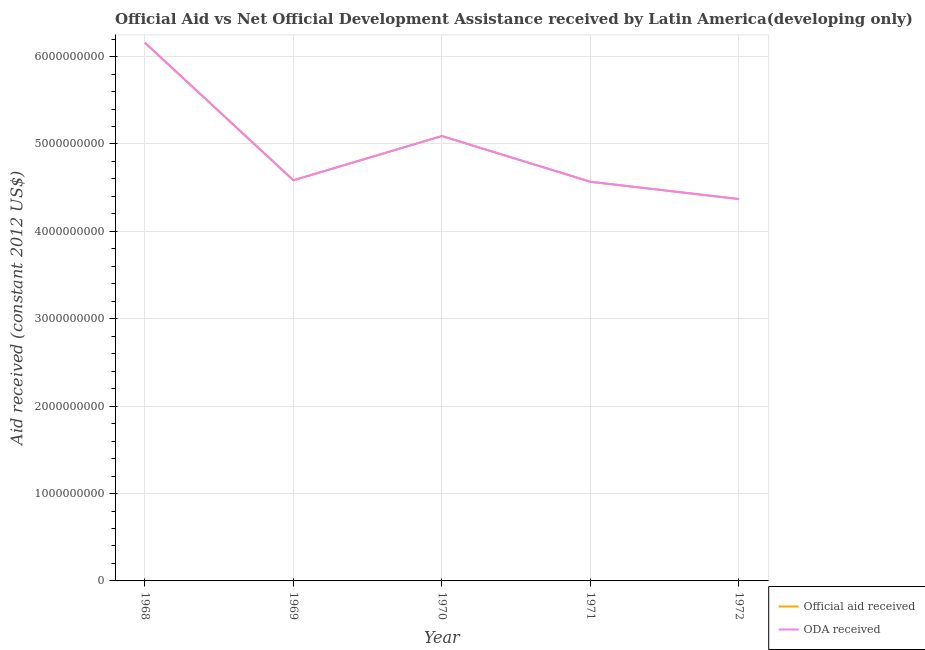How many different coloured lines are there?
Your answer should be very brief. 2. Is the number of lines equal to the number of legend labels?
Make the answer very short. Yes. What is the official aid received in 1969?
Your answer should be compact. 4.58e+09. Across all years, what is the maximum oda received?
Provide a short and direct response. 6.16e+09. Across all years, what is the minimum official aid received?
Offer a terse response. 4.37e+09. In which year was the official aid received maximum?
Give a very brief answer. 1968. What is the total official aid received in the graph?
Give a very brief answer. 2.48e+1. What is the difference between the official aid received in 1969 and that in 1971?
Make the answer very short. 1.72e+07. What is the difference between the oda received in 1971 and the official aid received in 1968?
Provide a short and direct response. -1.59e+09. What is the average official aid received per year?
Give a very brief answer. 4.95e+09. In the year 1969, what is the difference between the oda received and official aid received?
Keep it short and to the point. 0. What is the ratio of the oda received in 1968 to that in 1970?
Your response must be concise. 1.21. Is the difference between the oda received in 1971 and 1972 greater than the difference between the official aid received in 1971 and 1972?
Your response must be concise. No. What is the difference between the highest and the second highest official aid received?
Give a very brief answer. 1.07e+09. What is the difference between the highest and the lowest oda received?
Keep it short and to the point. 1.79e+09. In how many years, is the oda received greater than the average oda received taken over all years?
Your response must be concise. 2. Does the official aid received monotonically increase over the years?
Give a very brief answer. No. Is the official aid received strictly less than the oda received over the years?
Give a very brief answer. No. How many lines are there?
Keep it short and to the point. 2. What is the difference between two consecutive major ticks on the Y-axis?
Your response must be concise. 1.00e+09. What is the title of the graph?
Keep it short and to the point. Official Aid vs Net Official Development Assistance received by Latin America(developing only) . Does "Crop" appear as one of the legend labels in the graph?
Ensure brevity in your answer.  No. What is the label or title of the X-axis?
Provide a succinct answer. Year. What is the label or title of the Y-axis?
Your response must be concise. Aid received (constant 2012 US$). What is the Aid received (constant 2012 US$) in Official aid received in 1968?
Provide a short and direct response. 6.16e+09. What is the Aid received (constant 2012 US$) of ODA received in 1968?
Provide a short and direct response. 6.16e+09. What is the Aid received (constant 2012 US$) of Official aid received in 1969?
Provide a succinct answer. 4.58e+09. What is the Aid received (constant 2012 US$) in ODA received in 1969?
Provide a succinct answer. 4.58e+09. What is the Aid received (constant 2012 US$) of Official aid received in 1970?
Ensure brevity in your answer.  5.09e+09. What is the Aid received (constant 2012 US$) of ODA received in 1970?
Your answer should be compact. 5.09e+09. What is the Aid received (constant 2012 US$) of Official aid received in 1971?
Offer a very short reply. 4.57e+09. What is the Aid received (constant 2012 US$) of ODA received in 1971?
Offer a terse response. 4.57e+09. What is the Aid received (constant 2012 US$) of Official aid received in 1972?
Ensure brevity in your answer.  4.37e+09. What is the Aid received (constant 2012 US$) of ODA received in 1972?
Ensure brevity in your answer.  4.37e+09. Across all years, what is the maximum Aid received (constant 2012 US$) of Official aid received?
Provide a short and direct response. 6.16e+09. Across all years, what is the maximum Aid received (constant 2012 US$) in ODA received?
Ensure brevity in your answer.  6.16e+09. Across all years, what is the minimum Aid received (constant 2012 US$) of Official aid received?
Your answer should be compact. 4.37e+09. Across all years, what is the minimum Aid received (constant 2012 US$) of ODA received?
Offer a very short reply. 4.37e+09. What is the total Aid received (constant 2012 US$) of Official aid received in the graph?
Make the answer very short. 2.48e+1. What is the total Aid received (constant 2012 US$) of ODA received in the graph?
Your answer should be compact. 2.48e+1. What is the difference between the Aid received (constant 2012 US$) in Official aid received in 1968 and that in 1969?
Offer a very short reply. 1.57e+09. What is the difference between the Aid received (constant 2012 US$) of ODA received in 1968 and that in 1969?
Ensure brevity in your answer.  1.57e+09. What is the difference between the Aid received (constant 2012 US$) of Official aid received in 1968 and that in 1970?
Make the answer very short. 1.07e+09. What is the difference between the Aid received (constant 2012 US$) in ODA received in 1968 and that in 1970?
Keep it short and to the point. 1.07e+09. What is the difference between the Aid received (constant 2012 US$) of Official aid received in 1968 and that in 1971?
Give a very brief answer. 1.59e+09. What is the difference between the Aid received (constant 2012 US$) in ODA received in 1968 and that in 1971?
Offer a terse response. 1.59e+09. What is the difference between the Aid received (constant 2012 US$) of Official aid received in 1968 and that in 1972?
Your answer should be compact. 1.79e+09. What is the difference between the Aid received (constant 2012 US$) in ODA received in 1968 and that in 1972?
Your answer should be very brief. 1.79e+09. What is the difference between the Aid received (constant 2012 US$) in Official aid received in 1969 and that in 1970?
Offer a very short reply. -5.06e+08. What is the difference between the Aid received (constant 2012 US$) in ODA received in 1969 and that in 1970?
Your answer should be very brief. -5.06e+08. What is the difference between the Aid received (constant 2012 US$) in Official aid received in 1969 and that in 1971?
Keep it short and to the point. 1.72e+07. What is the difference between the Aid received (constant 2012 US$) of ODA received in 1969 and that in 1971?
Offer a terse response. 1.72e+07. What is the difference between the Aid received (constant 2012 US$) of Official aid received in 1969 and that in 1972?
Provide a short and direct response. 2.15e+08. What is the difference between the Aid received (constant 2012 US$) in ODA received in 1969 and that in 1972?
Your answer should be very brief. 2.15e+08. What is the difference between the Aid received (constant 2012 US$) of Official aid received in 1970 and that in 1971?
Your response must be concise. 5.23e+08. What is the difference between the Aid received (constant 2012 US$) in ODA received in 1970 and that in 1971?
Your response must be concise. 5.23e+08. What is the difference between the Aid received (constant 2012 US$) of Official aid received in 1970 and that in 1972?
Your response must be concise. 7.21e+08. What is the difference between the Aid received (constant 2012 US$) in ODA received in 1970 and that in 1972?
Your answer should be very brief. 7.21e+08. What is the difference between the Aid received (constant 2012 US$) in Official aid received in 1971 and that in 1972?
Your answer should be compact. 1.98e+08. What is the difference between the Aid received (constant 2012 US$) in ODA received in 1971 and that in 1972?
Provide a short and direct response. 1.98e+08. What is the difference between the Aid received (constant 2012 US$) in Official aid received in 1968 and the Aid received (constant 2012 US$) in ODA received in 1969?
Ensure brevity in your answer.  1.57e+09. What is the difference between the Aid received (constant 2012 US$) of Official aid received in 1968 and the Aid received (constant 2012 US$) of ODA received in 1970?
Your answer should be very brief. 1.07e+09. What is the difference between the Aid received (constant 2012 US$) of Official aid received in 1968 and the Aid received (constant 2012 US$) of ODA received in 1971?
Give a very brief answer. 1.59e+09. What is the difference between the Aid received (constant 2012 US$) of Official aid received in 1968 and the Aid received (constant 2012 US$) of ODA received in 1972?
Ensure brevity in your answer.  1.79e+09. What is the difference between the Aid received (constant 2012 US$) in Official aid received in 1969 and the Aid received (constant 2012 US$) in ODA received in 1970?
Your answer should be very brief. -5.06e+08. What is the difference between the Aid received (constant 2012 US$) in Official aid received in 1969 and the Aid received (constant 2012 US$) in ODA received in 1971?
Offer a very short reply. 1.72e+07. What is the difference between the Aid received (constant 2012 US$) of Official aid received in 1969 and the Aid received (constant 2012 US$) of ODA received in 1972?
Your answer should be very brief. 2.15e+08. What is the difference between the Aid received (constant 2012 US$) of Official aid received in 1970 and the Aid received (constant 2012 US$) of ODA received in 1971?
Offer a terse response. 5.23e+08. What is the difference between the Aid received (constant 2012 US$) in Official aid received in 1970 and the Aid received (constant 2012 US$) in ODA received in 1972?
Your answer should be very brief. 7.21e+08. What is the difference between the Aid received (constant 2012 US$) of Official aid received in 1971 and the Aid received (constant 2012 US$) of ODA received in 1972?
Your response must be concise. 1.98e+08. What is the average Aid received (constant 2012 US$) in Official aid received per year?
Offer a very short reply. 4.95e+09. What is the average Aid received (constant 2012 US$) in ODA received per year?
Ensure brevity in your answer.  4.95e+09. In the year 1969, what is the difference between the Aid received (constant 2012 US$) of Official aid received and Aid received (constant 2012 US$) of ODA received?
Your answer should be compact. 0. In the year 1970, what is the difference between the Aid received (constant 2012 US$) in Official aid received and Aid received (constant 2012 US$) in ODA received?
Give a very brief answer. 0. What is the ratio of the Aid received (constant 2012 US$) in Official aid received in 1968 to that in 1969?
Your answer should be very brief. 1.34. What is the ratio of the Aid received (constant 2012 US$) of ODA received in 1968 to that in 1969?
Give a very brief answer. 1.34. What is the ratio of the Aid received (constant 2012 US$) of Official aid received in 1968 to that in 1970?
Your answer should be very brief. 1.21. What is the ratio of the Aid received (constant 2012 US$) in ODA received in 1968 to that in 1970?
Provide a short and direct response. 1.21. What is the ratio of the Aid received (constant 2012 US$) in Official aid received in 1968 to that in 1971?
Give a very brief answer. 1.35. What is the ratio of the Aid received (constant 2012 US$) of ODA received in 1968 to that in 1971?
Your answer should be very brief. 1.35. What is the ratio of the Aid received (constant 2012 US$) of Official aid received in 1968 to that in 1972?
Ensure brevity in your answer.  1.41. What is the ratio of the Aid received (constant 2012 US$) in ODA received in 1968 to that in 1972?
Keep it short and to the point. 1.41. What is the ratio of the Aid received (constant 2012 US$) in Official aid received in 1969 to that in 1970?
Offer a very short reply. 0.9. What is the ratio of the Aid received (constant 2012 US$) of ODA received in 1969 to that in 1970?
Offer a terse response. 0.9. What is the ratio of the Aid received (constant 2012 US$) of ODA received in 1969 to that in 1971?
Your response must be concise. 1. What is the ratio of the Aid received (constant 2012 US$) in Official aid received in 1969 to that in 1972?
Your answer should be very brief. 1.05. What is the ratio of the Aid received (constant 2012 US$) of ODA received in 1969 to that in 1972?
Keep it short and to the point. 1.05. What is the ratio of the Aid received (constant 2012 US$) of Official aid received in 1970 to that in 1971?
Your response must be concise. 1.11. What is the ratio of the Aid received (constant 2012 US$) of ODA received in 1970 to that in 1971?
Keep it short and to the point. 1.11. What is the ratio of the Aid received (constant 2012 US$) in Official aid received in 1970 to that in 1972?
Your answer should be compact. 1.17. What is the ratio of the Aid received (constant 2012 US$) of ODA received in 1970 to that in 1972?
Keep it short and to the point. 1.17. What is the ratio of the Aid received (constant 2012 US$) in Official aid received in 1971 to that in 1972?
Make the answer very short. 1.05. What is the ratio of the Aid received (constant 2012 US$) of ODA received in 1971 to that in 1972?
Offer a terse response. 1.05. What is the difference between the highest and the second highest Aid received (constant 2012 US$) of Official aid received?
Offer a very short reply. 1.07e+09. What is the difference between the highest and the second highest Aid received (constant 2012 US$) in ODA received?
Make the answer very short. 1.07e+09. What is the difference between the highest and the lowest Aid received (constant 2012 US$) of Official aid received?
Keep it short and to the point. 1.79e+09. What is the difference between the highest and the lowest Aid received (constant 2012 US$) of ODA received?
Your response must be concise. 1.79e+09. 